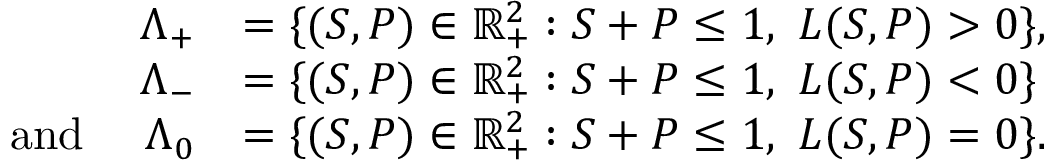Convert formula to latex. <formula><loc_0><loc_0><loc_500><loc_500>\begin{array} { r l } { \Lambda _ { + } } & { = \{ ( S , P ) \in \mathbb { R } _ { + } ^ { 2 } \colon S + P \leq 1 , \ L ( S , P ) > 0 \} , } \\ { \Lambda _ { - } } & { = \{ ( S , P ) \in \mathbb { R } _ { + } ^ { 2 } \colon S + P \leq 1 , \ L ( S , P ) < 0 \} } \\ { a n d \quad \Lambda _ { 0 } } & { = \{ ( S , P ) \in \mathbb { R } _ { + } ^ { 2 } \colon S + P \leq 1 , \ L ( S , P ) = 0 \} . } \end{array}</formula> 